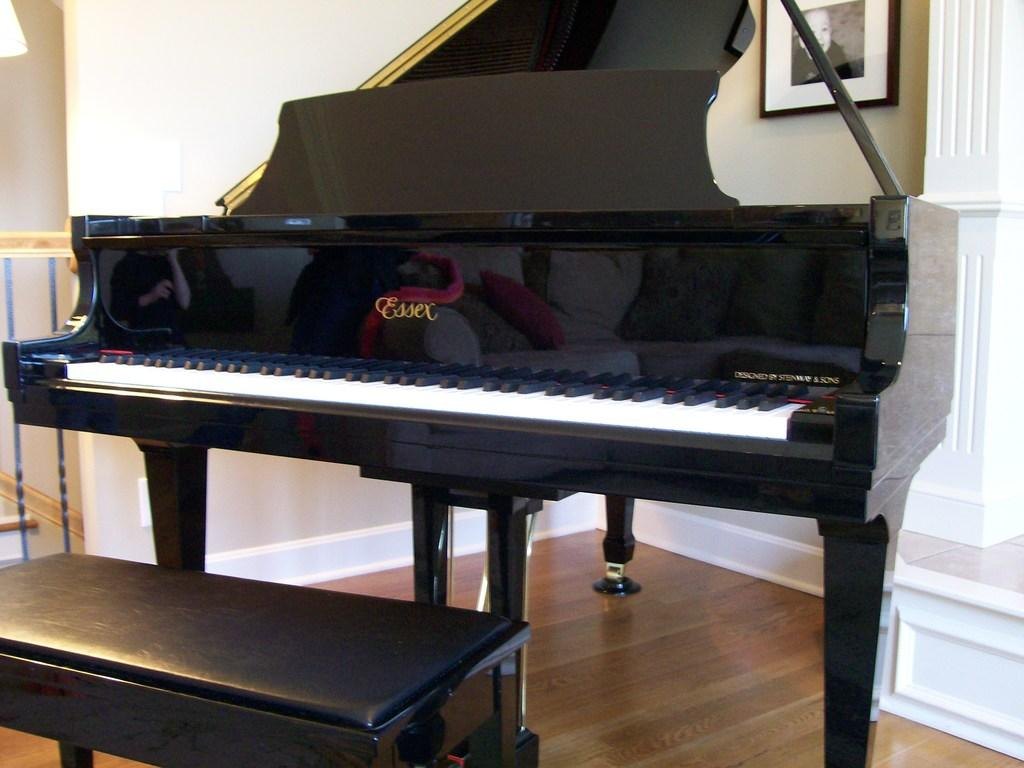What musical instrument is in the image? There is a piano in the image. What can be observed about the keys of the piano? The piano has black and white keys. What type of seating is near the piano? There is a black bench present near the piano. What is hanging on the wall to the right of the piano? A frame is visible on the wall to the right of the piano. What is the unusual feature seen to the left of the piano? A lump is seen to the left of the piano. What type of bean is growing near the piano in the image? There is no bean growing near the piano in the image. What calendar is hanging on the wall to the right of the piano? There is no calendar present in the image; only a frame is visible on the wall to the right of the piano. 